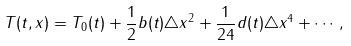Convert formula to latex. <formula><loc_0><loc_0><loc_500><loc_500>T ( t , x ) = T _ { 0 } ( t ) + \frac { 1 } { 2 } b ( t ) \triangle x ^ { 2 } + \frac { 1 } { 2 4 } d ( t ) \triangle x ^ { 4 } + \cdots ,</formula> 